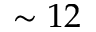<formula> <loc_0><loc_0><loc_500><loc_500>\sim 1 2</formula> 